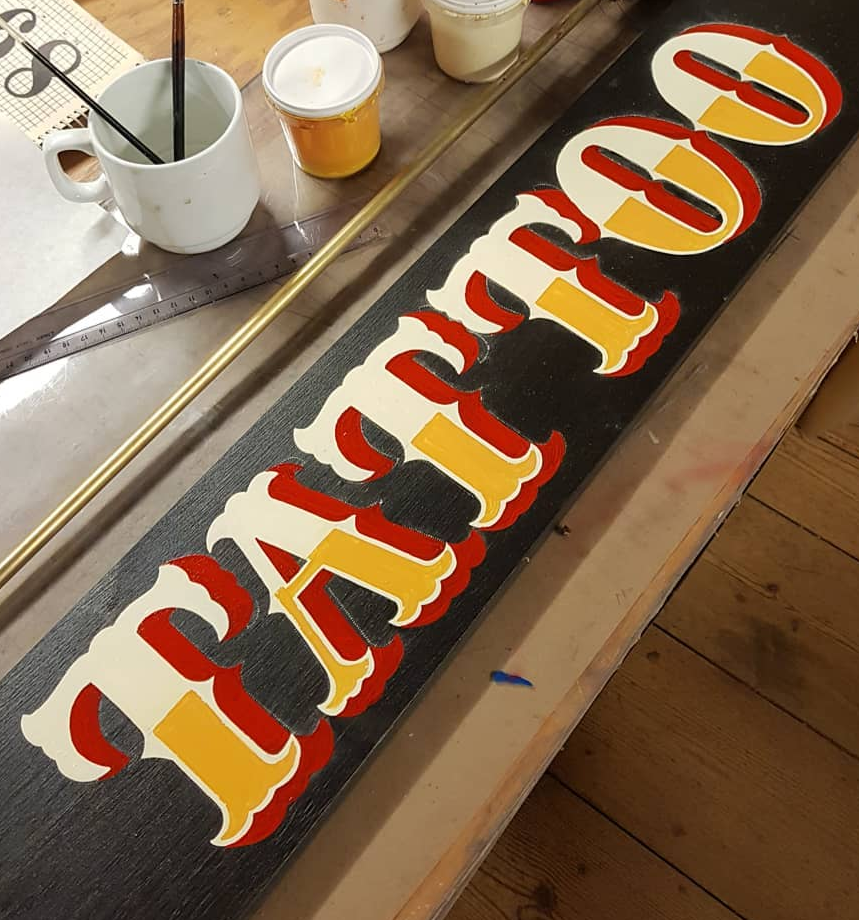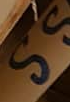What words are shown in these images in order, separated by a semicolon? TATTOO; SS 